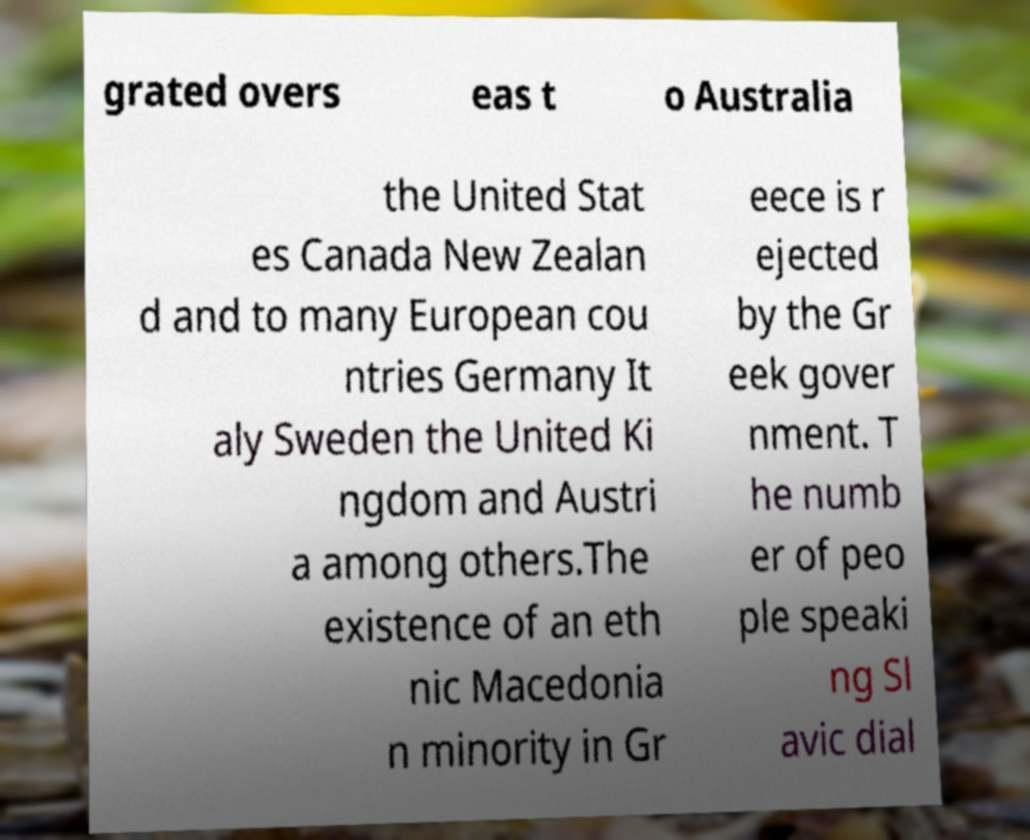Please read and relay the text visible in this image. What does it say? grated overs eas t o Australia the United Stat es Canada New Zealan d and to many European cou ntries Germany It aly Sweden the United Ki ngdom and Austri a among others.The existence of an eth nic Macedonia n minority in Gr eece is r ejected by the Gr eek gover nment. T he numb er of peo ple speaki ng Sl avic dial 